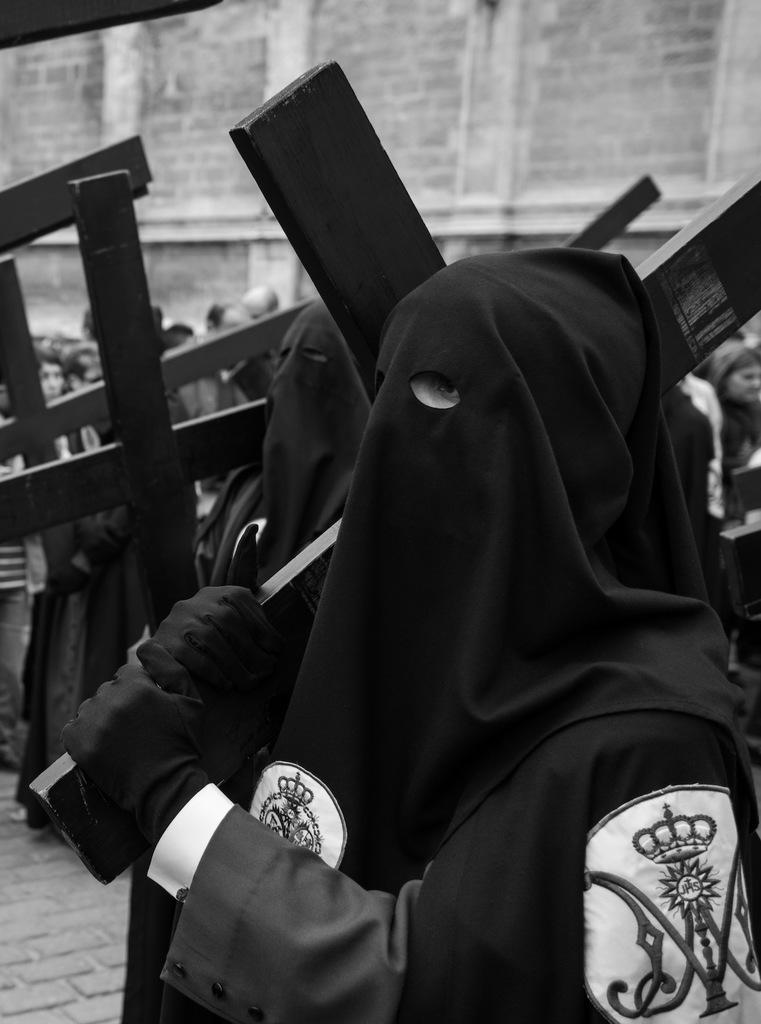What is the main subject in the foreground of the image? There is a man in the foreground of the image. What is the man wearing? The man is wearing a black dress. What is the man holding in his hand? The man is holding a cross symbolize structure in his hand. What can be seen in the background of the image? There is a crowd and a wall in the background of the image. Can you tell me how many times the man bites the cross symbolize structure in the image? There is no indication in the image that the man is biting the cross symbolize structure; he is simply holding it in his hand. 